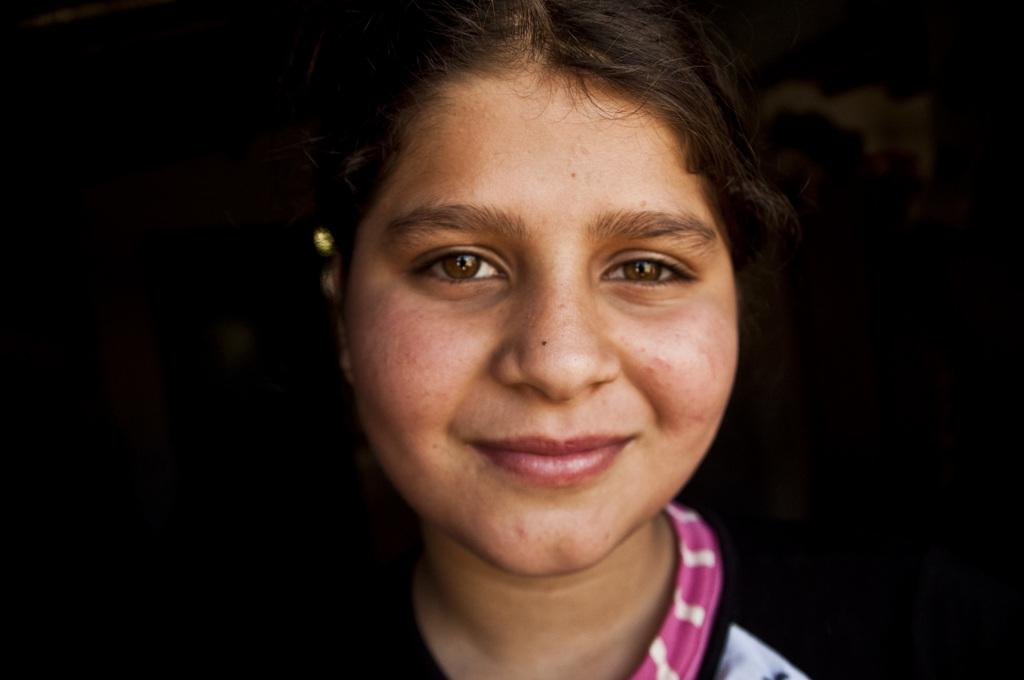Who is present in the image? There is a woman in the image. What is the woman's expression? The woman is smiling. What can be observed about the background of the image? The background of the image is dark. What type of story is the bee telling in the image? There is no bee present in the image, so it is not possible to determine what story it might be telling. 